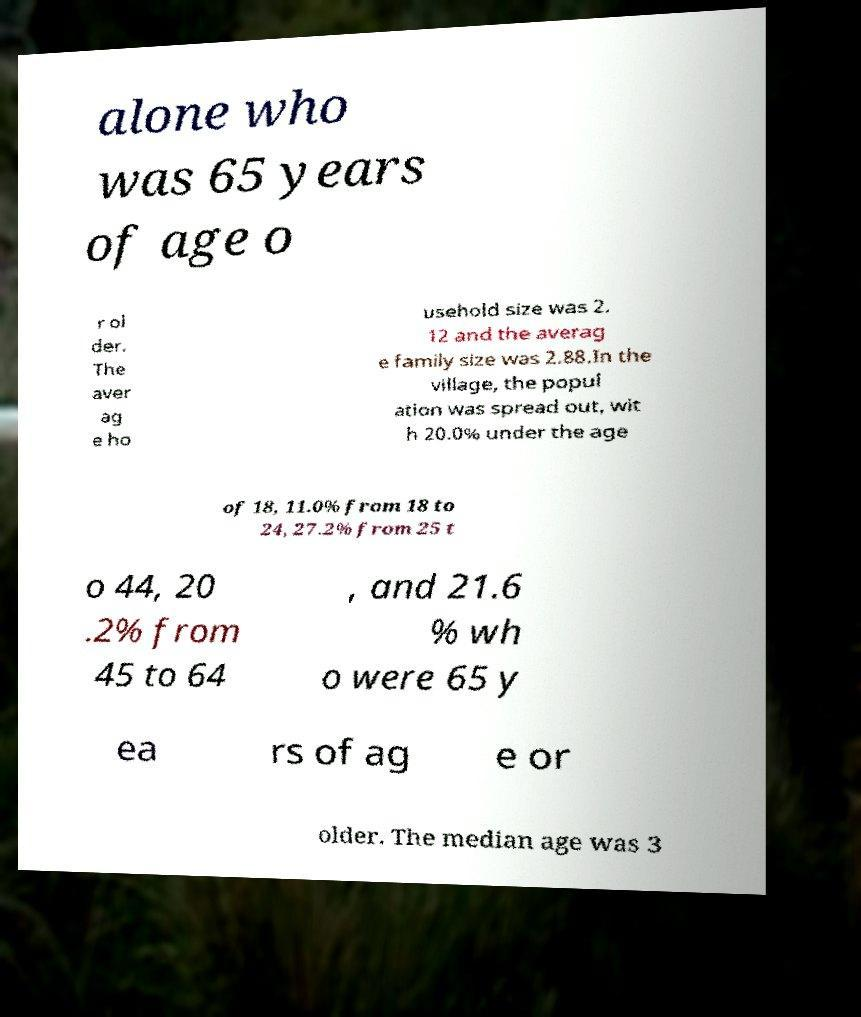Could you assist in decoding the text presented in this image and type it out clearly? alone who was 65 years of age o r ol der. The aver ag e ho usehold size was 2. 12 and the averag e family size was 2.88.In the village, the popul ation was spread out, wit h 20.0% under the age of 18, 11.0% from 18 to 24, 27.2% from 25 t o 44, 20 .2% from 45 to 64 , and 21.6 % wh o were 65 y ea rs of ag e or older. The median age was 3 